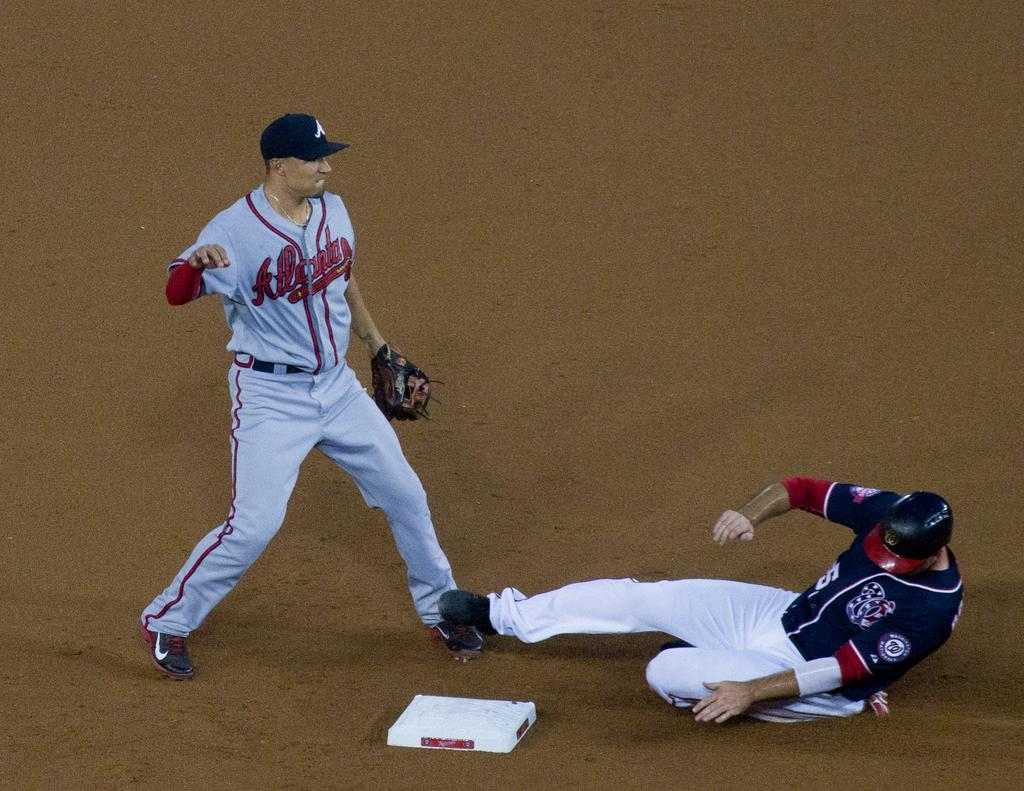<image>
Summarize the visual content of the image. Two sports players; the one on the floor has the number 5 on his shirt 